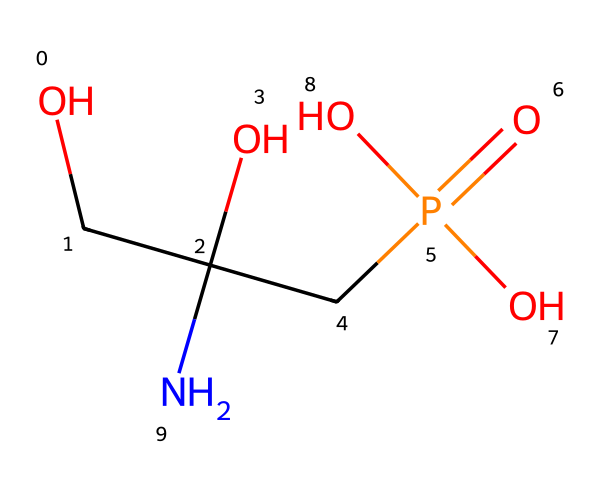What is the molecular formula of glyphosate? To determine the molecular formula, we count the number of each type of atom present in the SMILES representation. The chemical structure indicates: 3 carbon (C) atoms, 8 hydrogen (H) atoms, 1 nitrogen (N) atom, and 4 oxygen (O) atoms. Therefore, the molecular formula is C3H8N1O4.
Answer: C3H8N1O4 How many oxygen atoms are in glyphosate? We can identify the number of oxygen atoms directly from the SMILES representation where 'O' represents each oxygen atom. There are four oxygen atoms in total.
Answer: 4 What functional groups are present in glyphosate? By analyzing the chemical structure, we can identify the functional groups. Glyphosate contains an amine group (due to the nitrogen and adjacent hydrogens), a phosphonate group (indicated by the phosphorus atom and the bonded oxygens), and hydroxyl groups (the -OH groups), which are observable in the structure.
Answer: amine, phosphonate, hydroxyl What is the significance of the phosphorus atom in glyphosate? The presence of phosphorus in glyphosate implies that it functions as a phosphonate herbicide. This is significant because phosphonates are commonly used in herbicides to disrupt metabolic processes in plants. Thus, phosphorus plays a key role in its herbicidal activity.
Answer: herbicidal activity How many total atoms are in the glyphosate molecule? To calculate the total number of atoms, we add all the identified atoms: 3 carbon + 8 hydrogen + 1 nitrogen + 4 oxygen + 1 phosphorus = 17 atoms in total.
Answer: 17 What type of herbicide is glyphosate categorized as? Glyphosate is categorized as a broad-spectrum herbicide, which means it is effective against a wide variety of weeds and plants. This classification is based on its chemical structure and mechanism of action.
Answer: broad-spectrum 